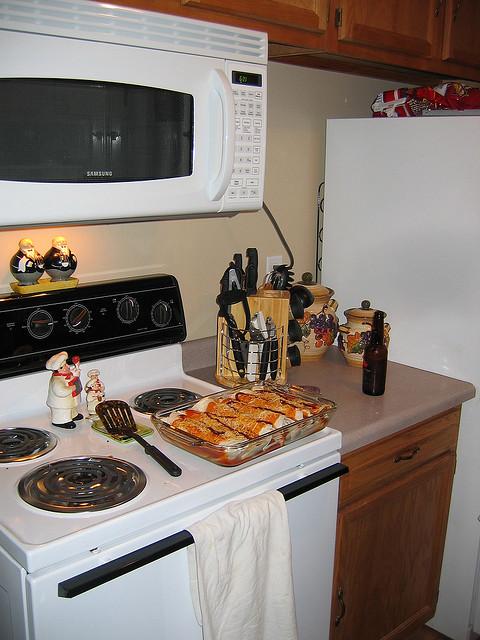Is the pan empty?
Be succinct. No. How big would this space be?
Concise answer only. Small. What utensil will be used to serve this food?
Short answer required. Spatula. Has any food been eaten yet?
Keep it brief. No. How many burners does the stove have?
Be succinct. 4. How would you describe the current likely occupancy of this kitchen?
Be succinct. Empty. What is the food in the pan?
Short answer required. Enchiladas. 